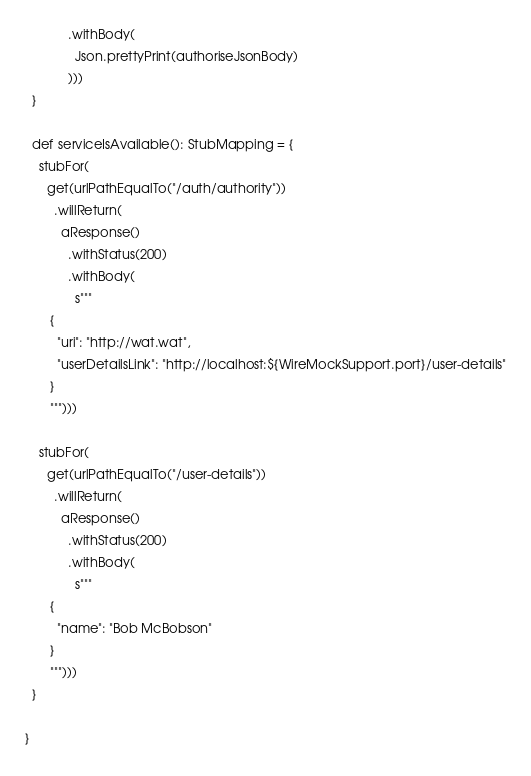<code> <loc_0><loc_0><loc_500><loc_500><_Scala_>            .withBody(
              Json.prettyPrint(authoriseJsonBody)
            )))
  }

  def serviceIsAvailable(): StubMapping = {
    stubFor(
      get(urlPathEqualTo("/auth/authority"))
        .willReturn(
          aResponse()
            .withStatus(200)
            .withBody(
              s"""
       {
         "uri": "http://wat.wat",
         "userDetailsLink": "http://localhost:${WireMockSupport.port}/user-details"
       }
       """)))

    stubFor(
      get(urlPathEqualTo("/user-details"))
        .willReturn(
          aResponse()
            .withStatus(200)
            .withBody(
              s"""
       {
         "name": "Bob McBobson"
       }
       """)))
  }

}
</code> 